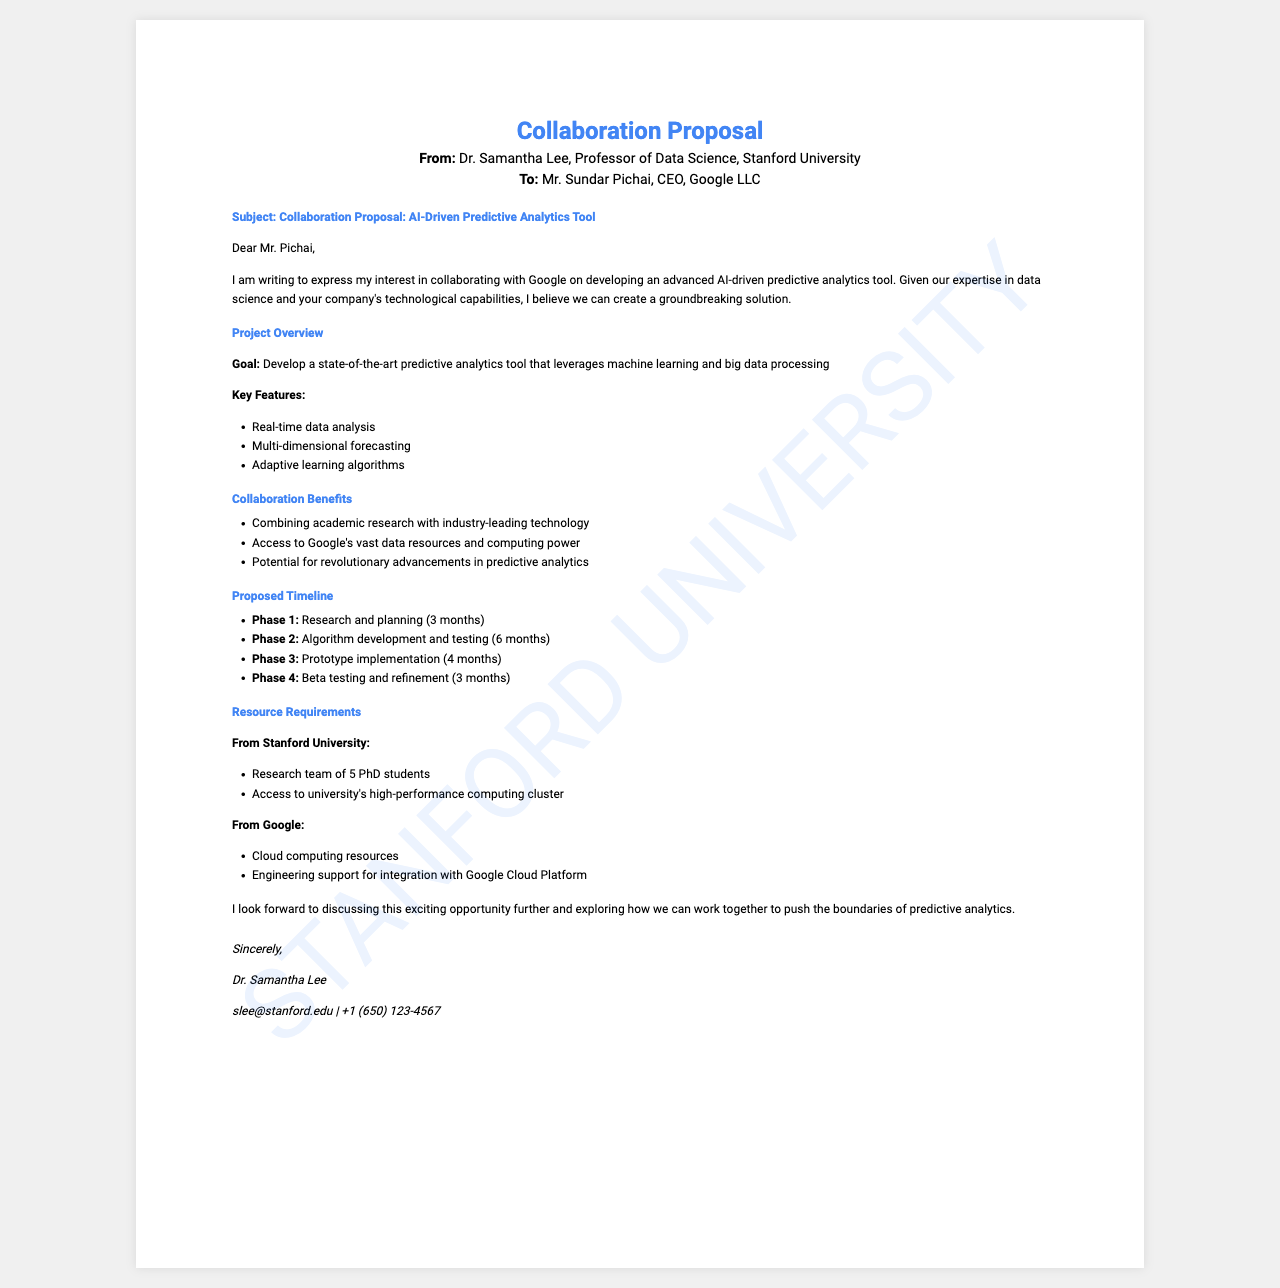What is the subject of the fax? The subject of the fax is stated in the subject section, which discusses the collaboration proposal for an AI-driven predictive analytics tool.
Answer: Collaboration Proposal: AI-Driven Predictive Analytics Tool Who is the sender of the fax? The sender is mentioned at the top of the document as Dr. Samantha Lee, Professor of Data Science.
Answer: Dr. Samantha Lee What is the proposed duration of Phase 1? The proposed duration is directly mentioned under the timeline section, specifying 3 months for the research and planning phase.
Answer: 3 months What is one of the key features of the proposed tool? The key features are listed, and one of them includes real-time data analysis.
Answer: Real-time data analysis How many PhD students are required from Stanford University? The requirement for the research team is noted in the resource requirements section, stating 5 PhD students.
Answer: 5 PhD students What role will Google provide in this collaboration? The role of Google is specified under resource requirements, including providing cloud computing resources.
Answer: Cloud computing resources How many phases are outlined in the proposed timeline? The proposed timeline outlines four distinct phases for the project.
Answer: Four phases What is the proposed benefit of this collaboration for Google? The document lists several benefits, one of which is access to Google's vast data resources and computing power.
Answer: Access to Google's vast data resources and computing power What is the email address of the sender? The sender's email address is provided in the signature section of the fax.
Answer: slee@stanford.edu 